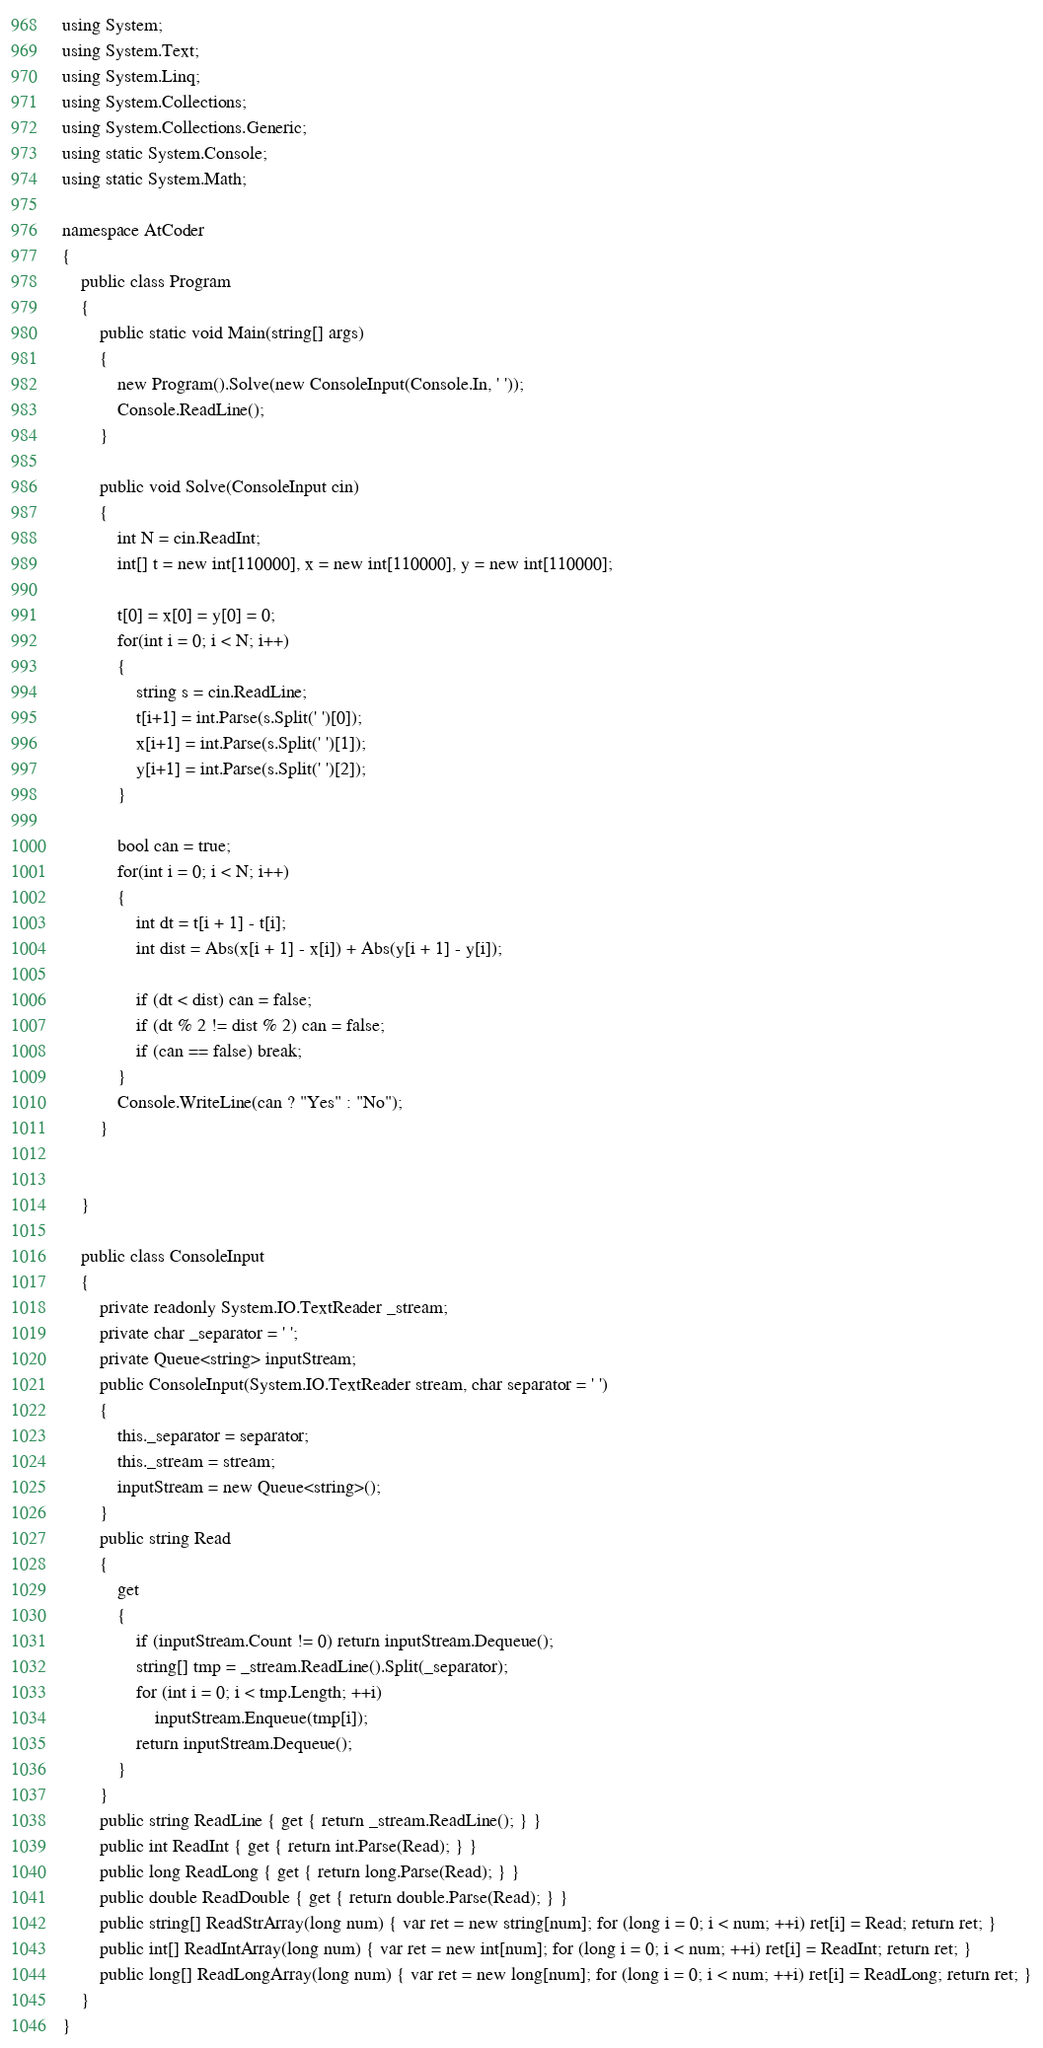<code> <loc_0><loc_0><loc_500><loc_500><_C#_>using System;
using System.Text;
using System.Linq;
using System.Collections;
using System.Collections.Generic;
using static System.Console;
using static System.Math;

namespace AtCoder
{
    public class Program
    {
        public static void Main(string[] args)
        {
            new Program().Solve(new ConsoleInput(Console.In, ' '));
            Console.ReadLine();
        }

        public void Solve(ConsoleInput cin)
        {
            int N = cin.ReadInt;
            int[] t = new int[110000], x = new int[110000], y = new int[110000];

            t[0] = x[0] = y[0] = 0;
            for(int i = 0; i < N; i++)
            {
                string s = cin.ReadLine;
                t[i+1] = int.Parse(s.Split(' ')[0]);
                x[i+1] = int.Parse(s.Split(' ')[1]);
                y[i+1] = int.Parse(s.Split(' ')[2]);
            }

            bool can = true;
            for(int i = 0; i < N; i++)
            {
                int dt = t[i + 1] - t[i];
                int dist = Abs(x[i + 1] - x[i]) + Abs(y[i + 1] - y[i]);

                if (dt < dist) can = false;
                if (dt % 2 != dist % 2) can = false;
                if (can == false) break;
            }
            Console.WriteLine(can ? "Yes" : "No");
        }


    }

    public class ConsoleInput
    {
        private readonly System.IO.TextReader _stream;
        private char _separator = ' ';
        private Queue<string> inputStream;
        public ConsoleInput(System.IO.TextReader stream, char separator = ' ')
        {
            this._separator = separator;
            this._stream = stream;
            inputStream = new Queue<string>();
        }
        public string Read
        {
            get
            {
                if (inputStream.Count != 0) return inputStream.Dequeue();
                string[] tmp = _stream.ReadLine().Split(_separator);
                for (int i = 0; i < tmp.Length; ++i)
                    inputStream.Enqueue(tmp[i]);
                return inputStream.Dequeue();
            }
        }
        public string ReadLine { get { return _stream.ReadLine(); } }
        public int ReadInt { get { return int.Parse(Read); } }
        public long ReadLong { get { return long.Parse(Read); } }
        public double ReadDouble { get { return double.Parse(Read); } }
        public string[] ReadStrArray(long num) { var ret = new string[num]; for (long i = 0; i < num; ++i) ret[i] = Read; return ret; }
        public int[] ReadIntArray(long num) { var ret = new int[num]; for (long i = 0; i < num; ++i) ret[i] = ReadInt; return ret; }
        public long[] ReadLongArray(long num) { var ret = new long[num]; for (long i = 0; i < num; ++i) ret[i] = ReadLong; return ret; }
    }
}</code> 